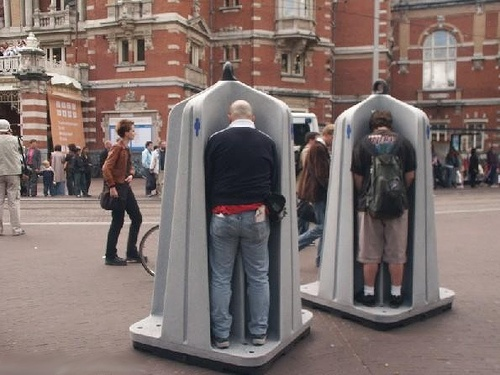Describe the objects in this image and their specific colors. I can see toilet in brown, gray, black, and lightgray tones, people in brown, black, and gray tones, people in brown, black, gray, and darkgray tones, people in brown, black, maroon, and gray tones, and people in brown, black, gray, and darkgray tones in this image. 